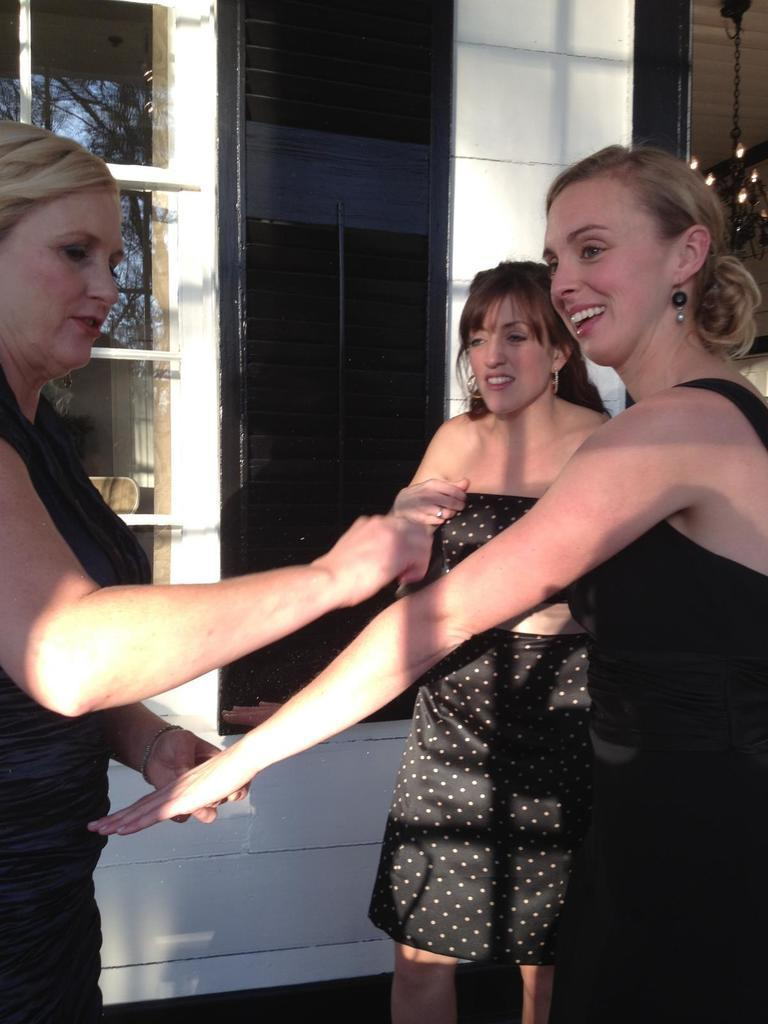How many women are in the image? There are three women in the image. What are the women doing in the image? The women are standing and holding hands. What are the women wearing in the image? The women are wearing black dresses. What can be seen in the background of the image? There is a building in the background of the image. What is a feature of the building in the image? The building has a wall with black glass. How many babies are present in the image? There are no babies present in the image; it features three women standing and holding hands. 